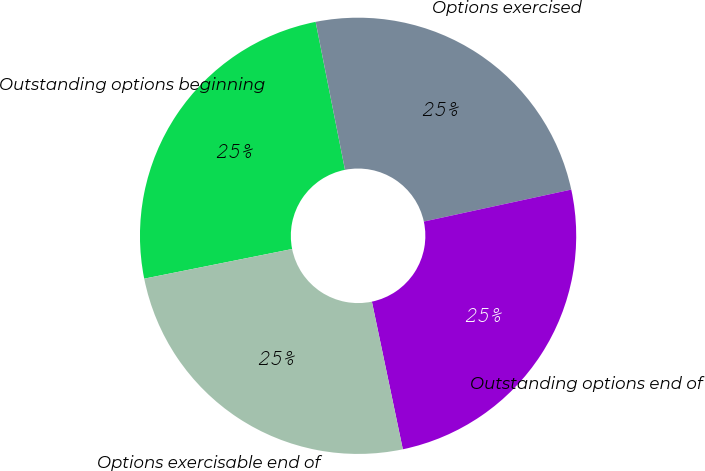<chart> <loc_0><loc_0><loc_500><loc_500><pie_chart><fcel>Outstanding options beginning<fcel>Options exercised<fcel>Outstanding options end of<fcel>Options exercisable end of<nl><fcel>25.03%<fcel>24.72%<fcel>25.11%<fcel>25.14%<nl></chart> 